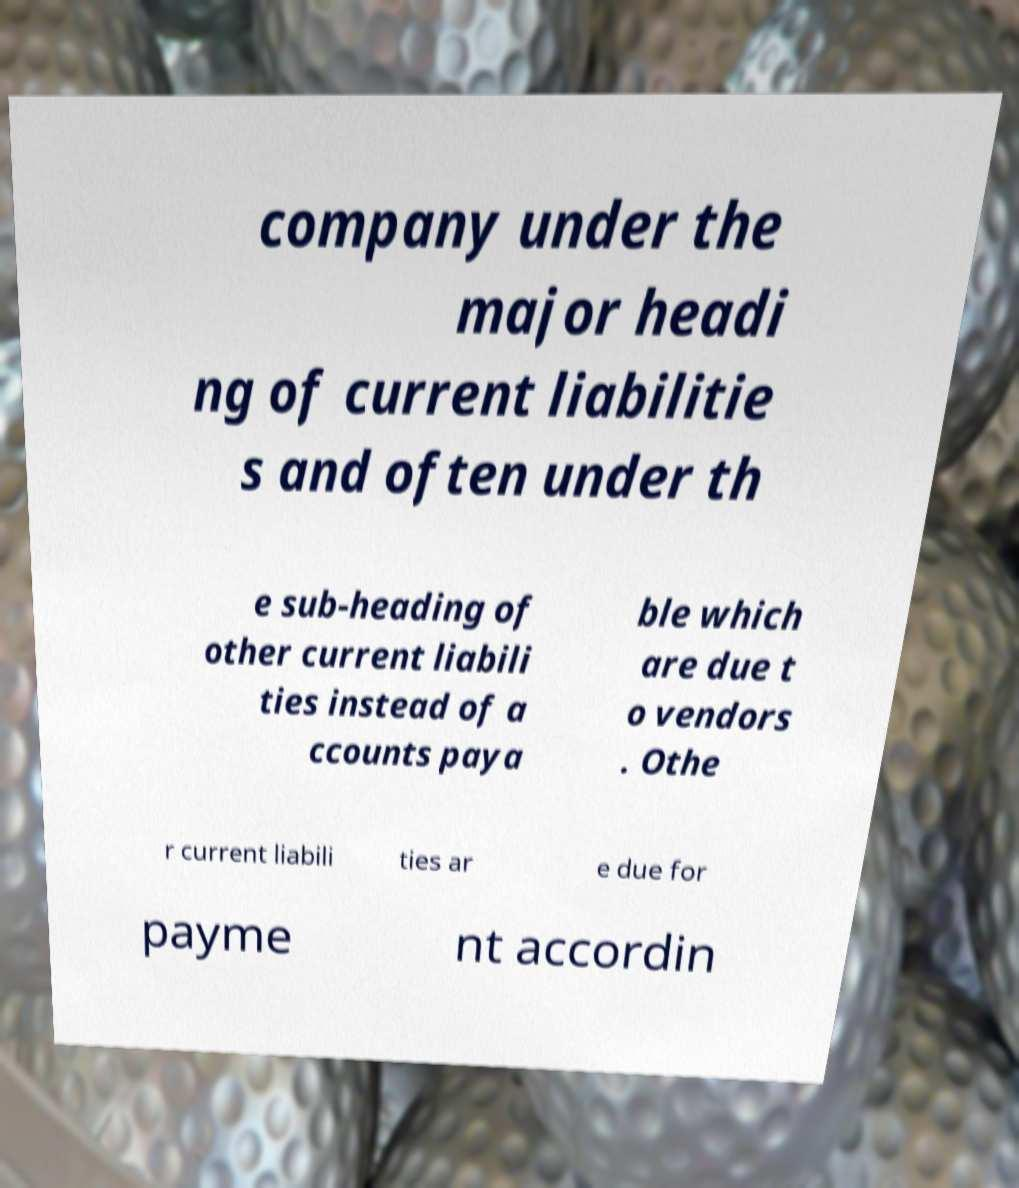Please identify and transcribe the text found in this image. company under the major headi ng of current liabilitie s and often under th e sub-heading of other current liabili ties instead of a ccounts paya ble which are due t o vendors . Othe r current liabili ties ar e due for payme nt accordin 